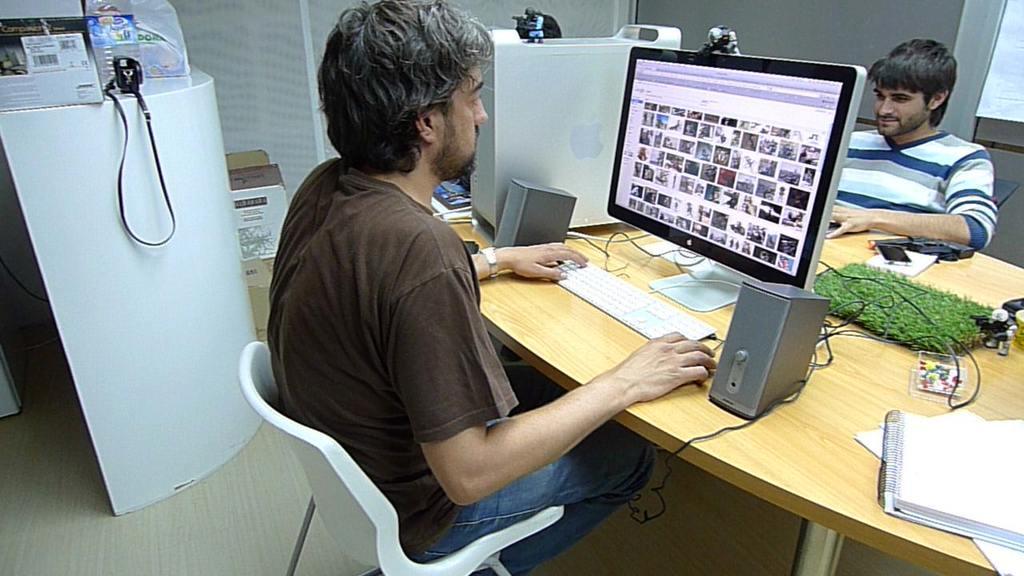Please provide a concise description of this image. In this image, there are two persons sitting on the chair in front of the system. In the middle bottom, there is a table on which system, grass, papers, keyboard and file is kept. In the left side of the image, there is a standing table on which boxes are kept. In the right middle of the image, there is a xerox machine which is white in color. In the right top of the image, we can see a window which is transparent. In the background there is a wall made up of glass. 